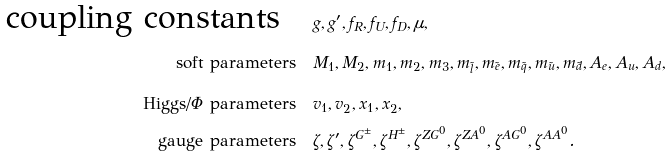Convert formula to latex. <formula><loc_0><loc_0><loc_500><loc_500>\text {coupling constants} \quad & g , g ^ { \prime } , f _ { R } , f _ { U } , f _ { D } , \mu , \\ \text {soft parameters} \quad & M _ { 1 } , M _ { 2 } , m _ { 1 } , m _ { 2 } , m _ { 3 } , m _ { \tilde { l } } , m _ { \tilde { e } } , m _ { \tilde { q } } , m _ { \tilde { u } } , m _ { \tilde { d } } , A _ { e } , A _ { u } , A _ { d } , \\ \text {Higgs/$\Phi$ parameters} \quad & v _ { 1 } , v _ { 2 } , x _ { 1 } , x _ { 2 } , \\ \text {gauge parameters} \quad & \zeta , \zeta ^ { \prime } , \zeta ^ { G ^ { \pm } } , \zeta ^ { H ^ { \pm } } , \zeta ^ { Z G ^ { 0 } } , \zeta ^ { Z A ^ { 0 } } , \zeta ^ { A G ^ { 0 } } , \zeta ^ { A A ^ { 0 } } .</formula> 